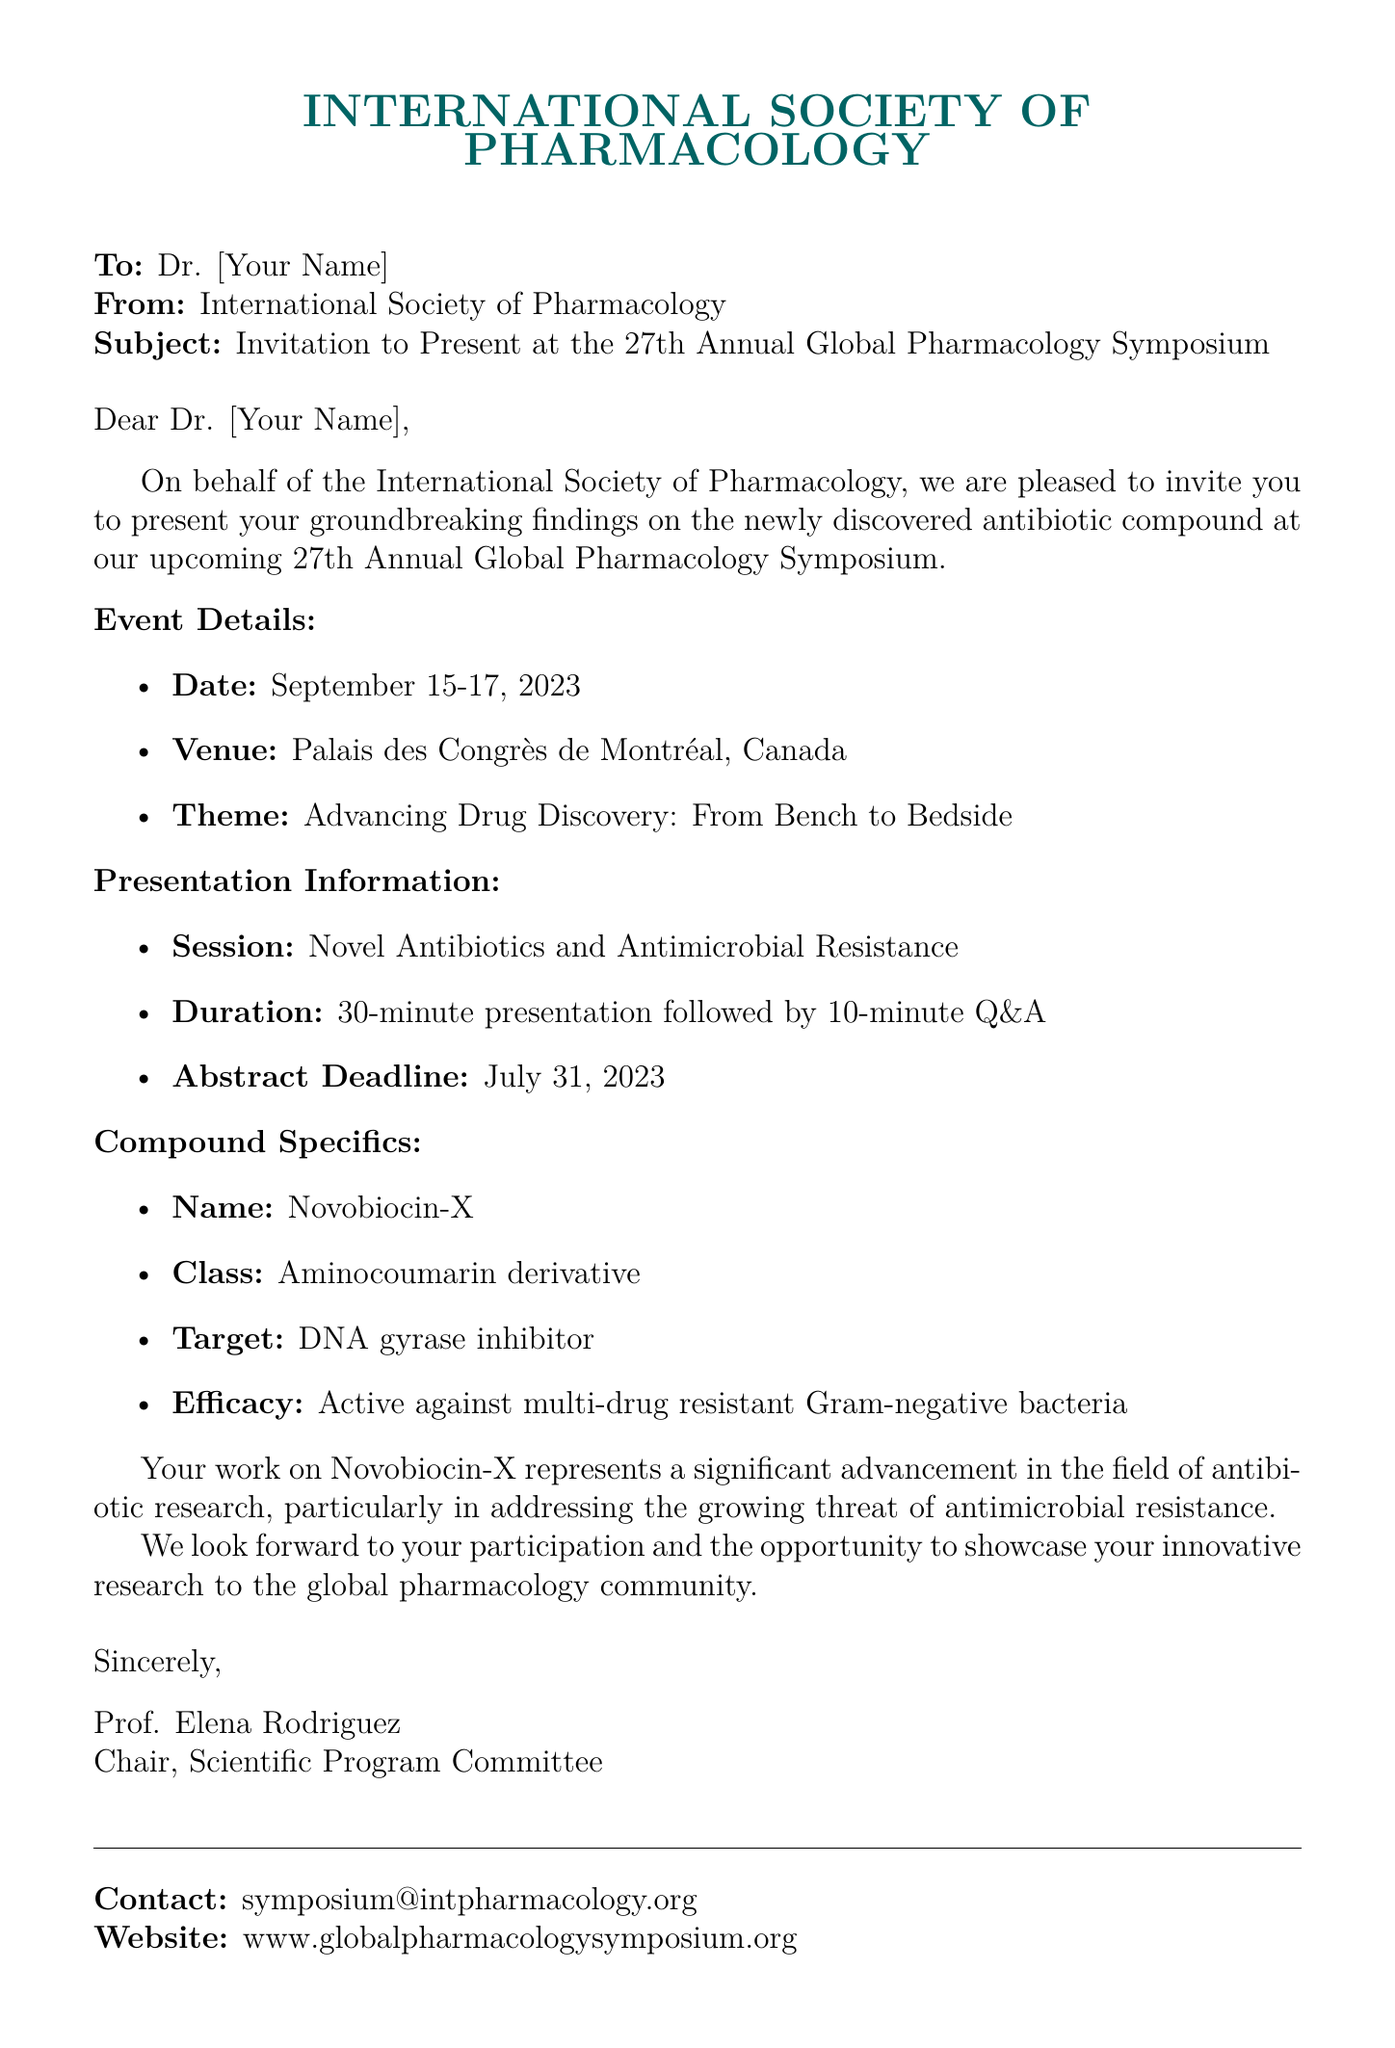what is the name of the antibiotic compound? The document specifies the name of the antibiotic compound as Novobiocin-X.
Answer: Novobiocin-X what is the date of the symposium? The event details list the date of the symposium as September 15-17, 2023.
Answer: September 15-17, 2023 how long is the presentation duration? The presentation information section states that the duration is a 30-minute presentation followed by a 10-minute Q&A.
Answer: 30 minutes who is the chair of the Scientific Program Committee? The closing section of the document indicates that Prof. Elena Rodriguez is the chair.
Answer: Prof. Elena Rodriguez what is the theme of the symposium? The document lists the theme of the symposium as "Advancing Drug Discovery: From Bench to Bedside."
Answer: Advancing Drug Discovery: From Bench to Bedside what type of bacteria is Novobiocin-X effective against? The compound specifics mention that Novobiocin-X is active against multi-drug resistant Gram-negative bacteria.
Answer: multi-drug resistant Gram-negative bacteria when is the abstract deadline? The presentation information specifies that the abstract deadline is July 31, 2023.
Answer: July 31, 2023 what class does Novobiocin-X belong to? The document states that Novobiocin-X is classified as an Aminocoumarin derivative.
Answer: Aminocoumarin derivative 